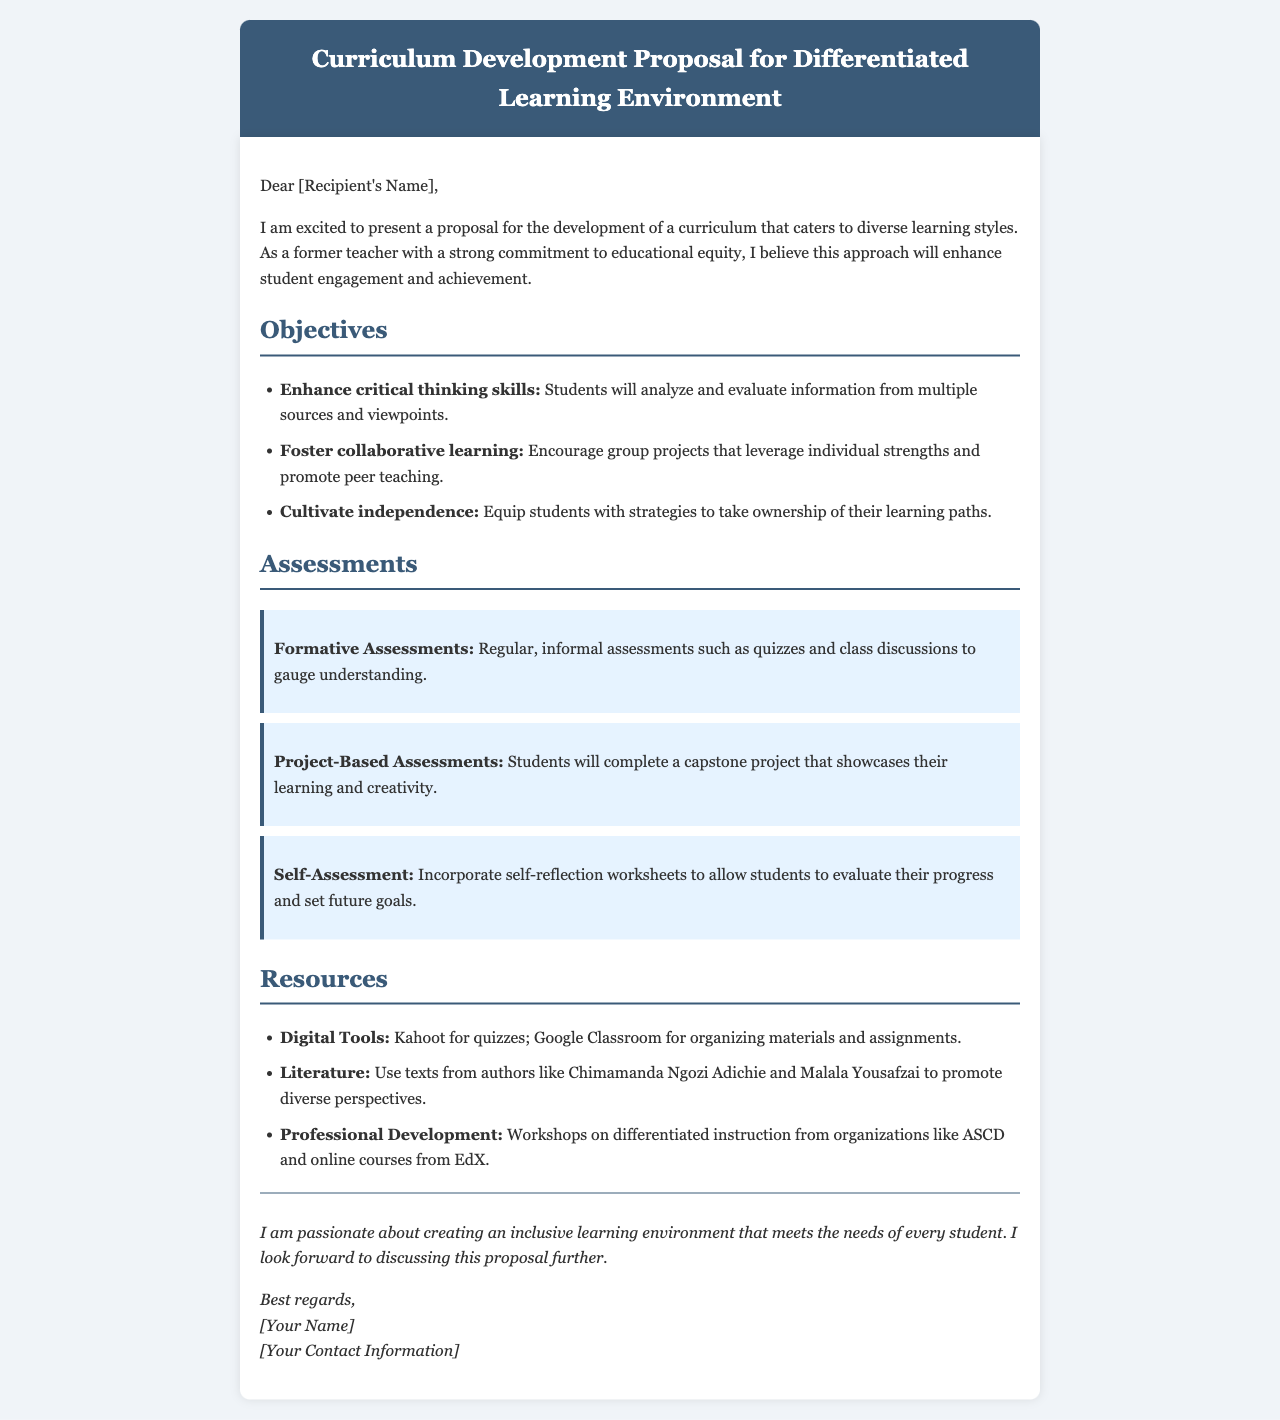What is the title of the proposal? The title of the proposal is found in the heading of the document.
Answer: Curriculum Development Proposal for Differentiated Learning Environment Who is the intended recipient of the proposal? The proposal is addressed to a recipient, which is indicated at the beginning of the content.
Answer: [Recipient's Name] How many objectives are outlined in the proposal? The number of objectives can be found in the section listing them.
Answer: Three What is one type of formative assessment mentioned? The document specifies examples of formative assessments used within the curriculum.
Answer: Quizzes Which digital tool is suggested for quizzes? The document refers to specific resources available for the curriculum development.
Answer: Kahoot What is the focus of the proposed project-based assessment? The project-based assessment is described to showcase student learning.
Answer: Capstone project Name one author used for literature resources. The document lists authors whose works promote diverse perspectives in the literature section.
Answer: Chimamanda Ngozi Adichie What organization's workshops are mentioned for professional development? The proposal includes sources for professional development workshops.
Answer: ASCD What is the concluding sentiment expressed in the proposal? The conclusion summarizes the proposer’s commitment and eagerness to further discuss the proposal.
Answer: Passionate about creating an inclusive learning environment 